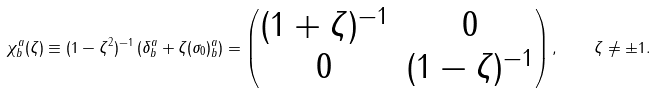<formula> <loc_0><loc_0><loc_500><loc_500>\chi _ { b } ^ { a } ( \zeta ) \equiv ( 1 - \zeta ^ { 2 } ) ^ { - 1 } \left ( \delta ^ { a } _ { b } + \zeta ( \sigma _ { 0 } ) ^ { a } _ { b } \right ) = \begin{pmatrix} ( 1 + \zeta ) ^ { - 1 } & 0 \\ 0 & ( 1 - \zeta ) ^ { - 1 } \end{pmatrix} , \quad \zeta \neq \pm 1 .</formula> 